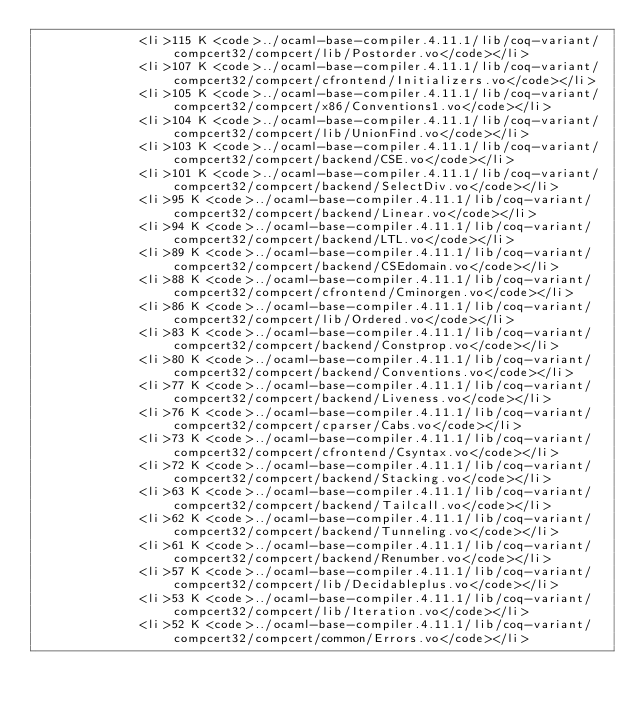Convert code to text. <code><loc_0><loc_0><loc_500><loc_500><_HTML_>              <li>115 K <code>../ocaml-base-compiler.4.11.1/lib/coq-variant/compcert32/compcert/lib/Postorder.vo</code></li>
              <li>107 K <code>../ocaml-base-compiler.4.11.1/lib/coq-variant/compcert32/compcert/cfrontend/Initializers.vo</code></li>
              <li>105 K <code>../ocaml-base-compiler.4.11.1/lib/coq-variant/compcert32/compcert/x86/Conventions1.vo</code></li>
              <li>104 K <code>../ocaml-base-compiler.4.11.1/lib/coq-variant/compcert32/compcert/lib/UnionFind.vo</code></li>
              <li>103 K <code>../ocaml-base-compiler.4.11.1/lib/coq-variant/compcert32/compcert/backend/CSE.vo</code></li>
              <li>101 K <code>../ocaml-base-compiler.4.11.1/lib/coq-variant/compcert32/compcert/backend/SelectDiv.vo</code></li>
              <li>95 K <code>../ocaml-base-compiler.4.11.1/lib/coq-variant/compcert32/compcert/backend/Linear.vo</code></li>
              <li>94 K <code>../ocaml-base-compiler.4.11.1/lib/coq-variant/compcert32/compcert/backend/LTL.vo</code></li>
              <li>89 K <code>../ocaml-base-compiler.4.11.1/lib/coq-variant/compcert32/compcert/backend/CSEdomain.vo</code></li>
              <li>88 K <code>../ocaml-base-compiler.4.11.1/lib/coq-variant/compcert32/compcert/cfrontend/Cminorgen.vo</code></li>
              <li>86 K <code>../ocaml-base-compiler.4.11.1/lib/coq-variant/compcert32/compcert/lib/Ordered.vo</code></li>
              <li>83 K <code>../ocaml-base-compiler.4.11.1/lib/coq-variant/compcert32/compcert/backend/Constprop.vo</code></li>
              <li>80 K <code>../ocaml-base-compiler.4.11.1/lib/coq-variant/compcert32/compcert/backend/Conventions.vo</code></li>
              <li>77 K <code>../ocaml-base-compiler.4.11.1/lib/coq-variant/compcert32/compcert/backend/Liveness.vo</code></li>
              <li>76 K <code>../ocaml-base-compiler.4.11.1/lib/coq-variant/compcert32/compcert/cparser/Cabs.vo</code></li>
              <li>73 K <code>../ocaml-base-compiler.4.11.1/lib/coq-variant/compcert32/compcert/cfrontend/Csyntax.vo</code></li>
              <li>72 K <code>../ocaml-base-compiler.4.11.1/lib/coq-variant/compcert32/compcert/backend/Stacking.vo</code></li>
              <li>63 K <code>../ocaml-base-compiler.4.11.1/lib/coq-variant/compcert32/compcert/backend/Tailcall.vo</code></li>
              <li>62 K <code>../ocaml-base-compiler.4.11.1/lib/coq-variant/compcert32/compcert/backend/Tunneling.vo</code></li>
              <li>61 K <code>../ocaml-base-compiler.4.11.1/lib/coq-variant/compcert32/compcert/backend/Renumber.vo</code></li>
              <li>57 K <code>../ocaml-base-compiler.4.11.1/lib/coq-variant/compcert32/compcert/lib/Decidableplus.vo</code></li>
              <li>53 K <code>../ocaml-base-compiler.4.11.1/lib/coq-variant/compcert32/compcert/lib/Iteration.vo</code></li>
              <li>52 K <code>../ocaml-base-compiler.4.11.1/lib/coq-variant/compcert32/compcert/common/Errors.vo</code></li></code> 